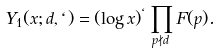<formula> <loc_0><loc_0><loc_500><loc_500>Y _ { 1 } ( x ; d , \ell ) = ( \log x ) ^ { \ell } \prod _ { p \nmid d } F ( p ) .</formula> 